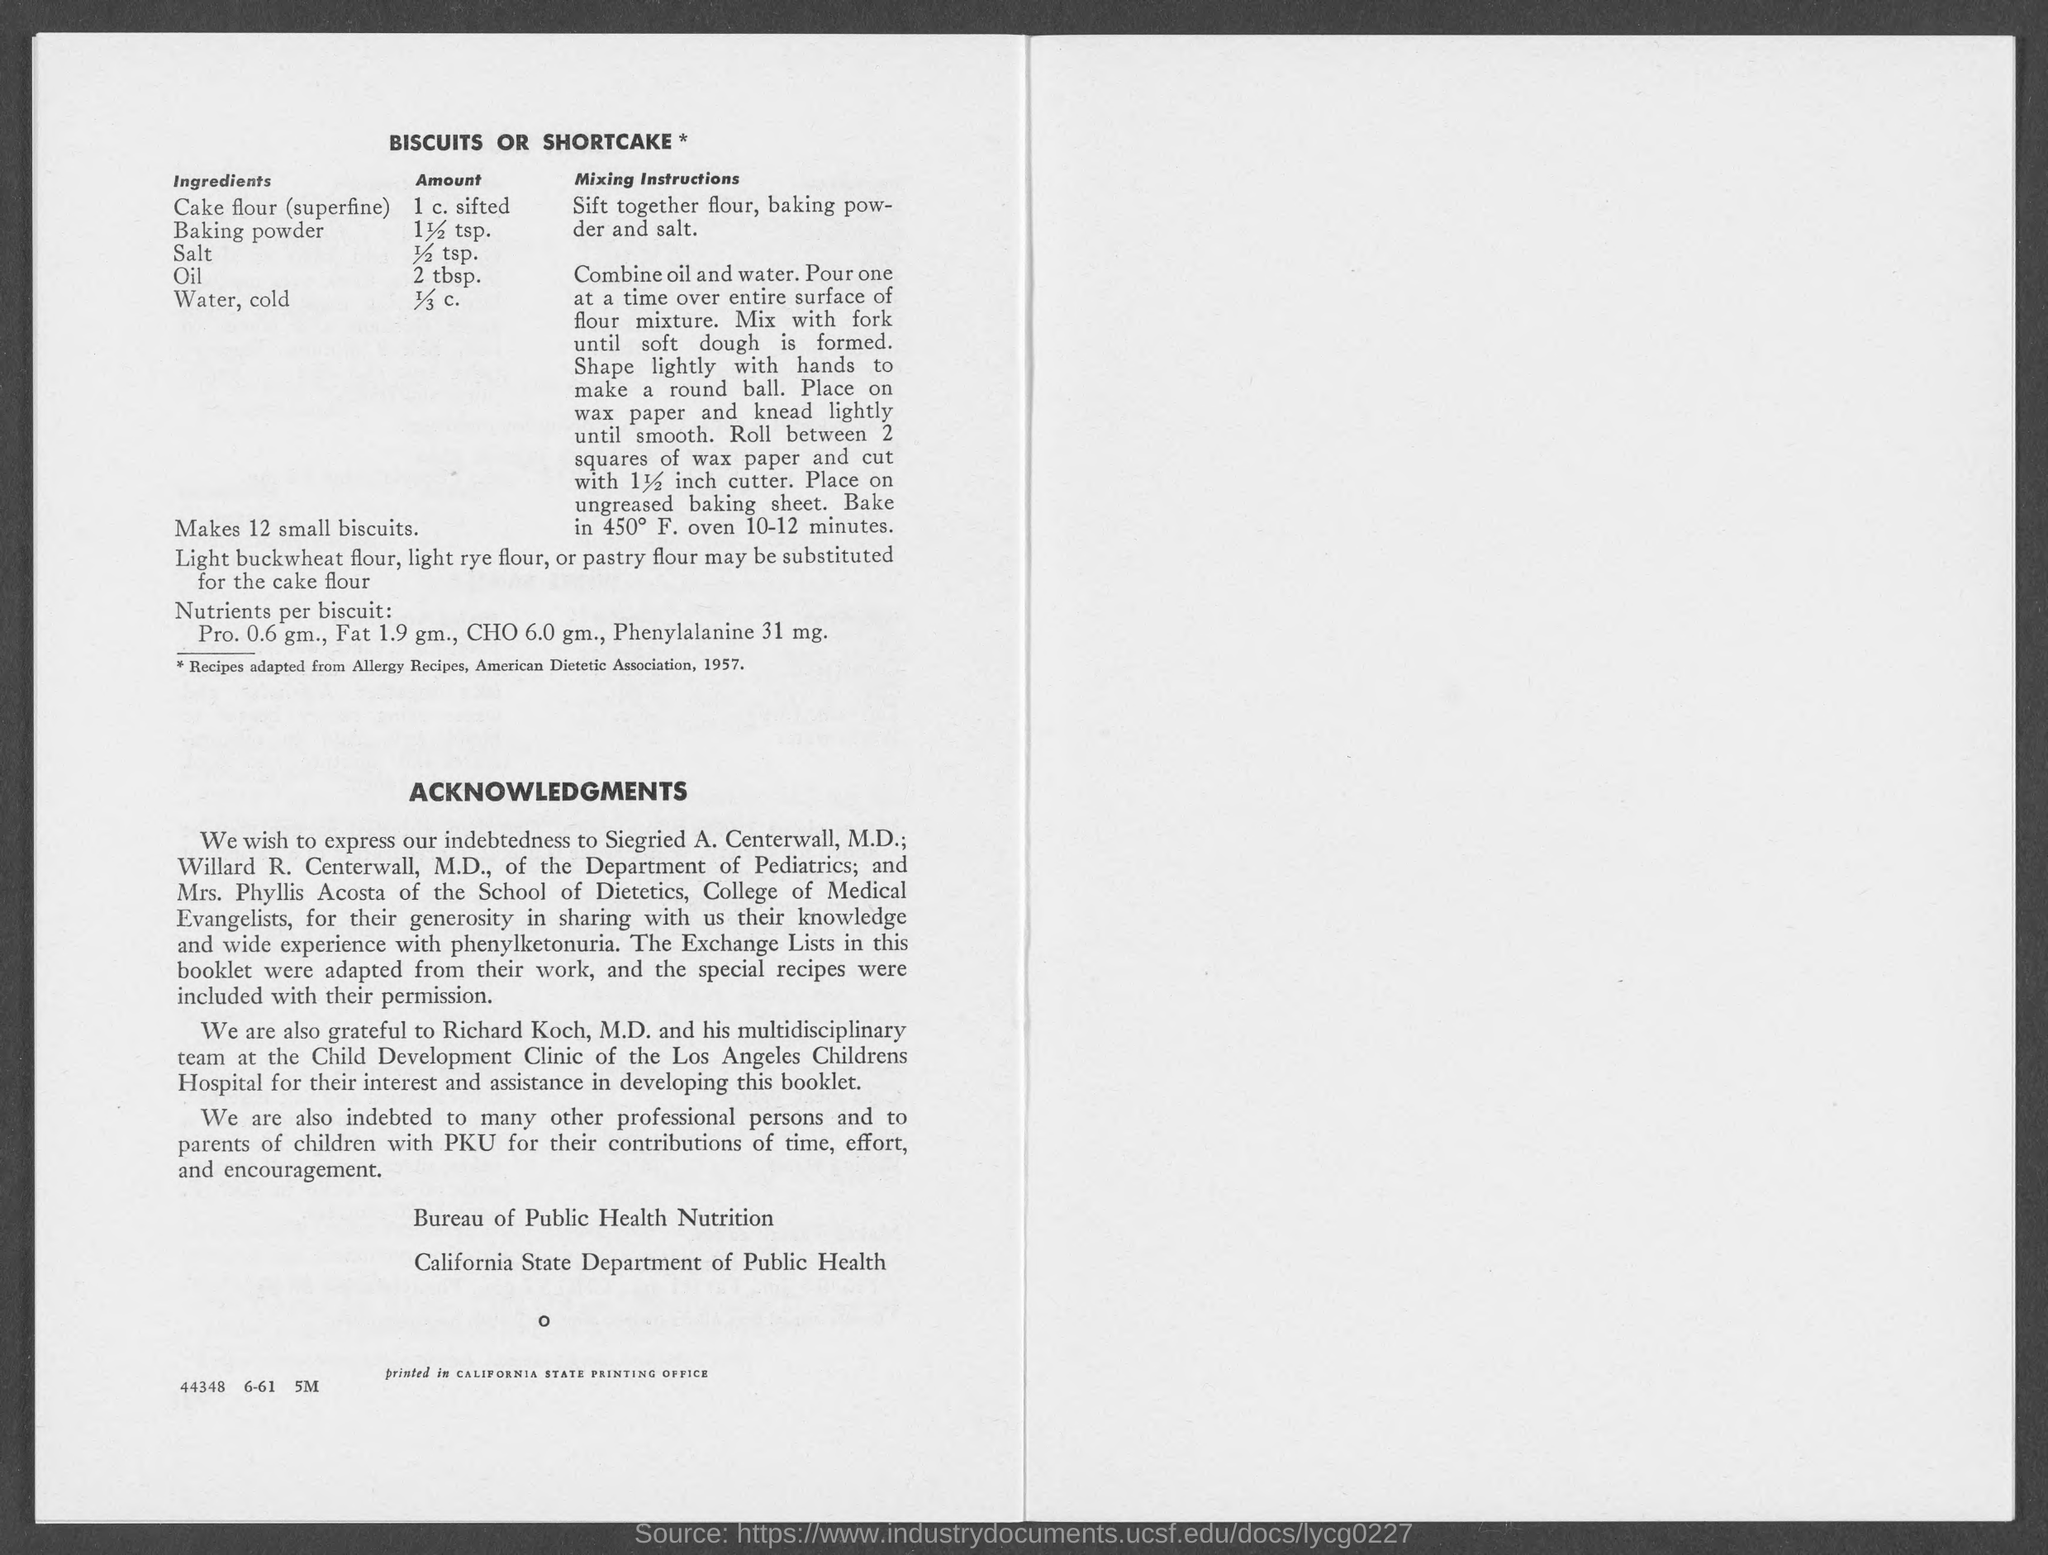What is the amount of salt?
Give a very brief answer. 1/2 TSP. 